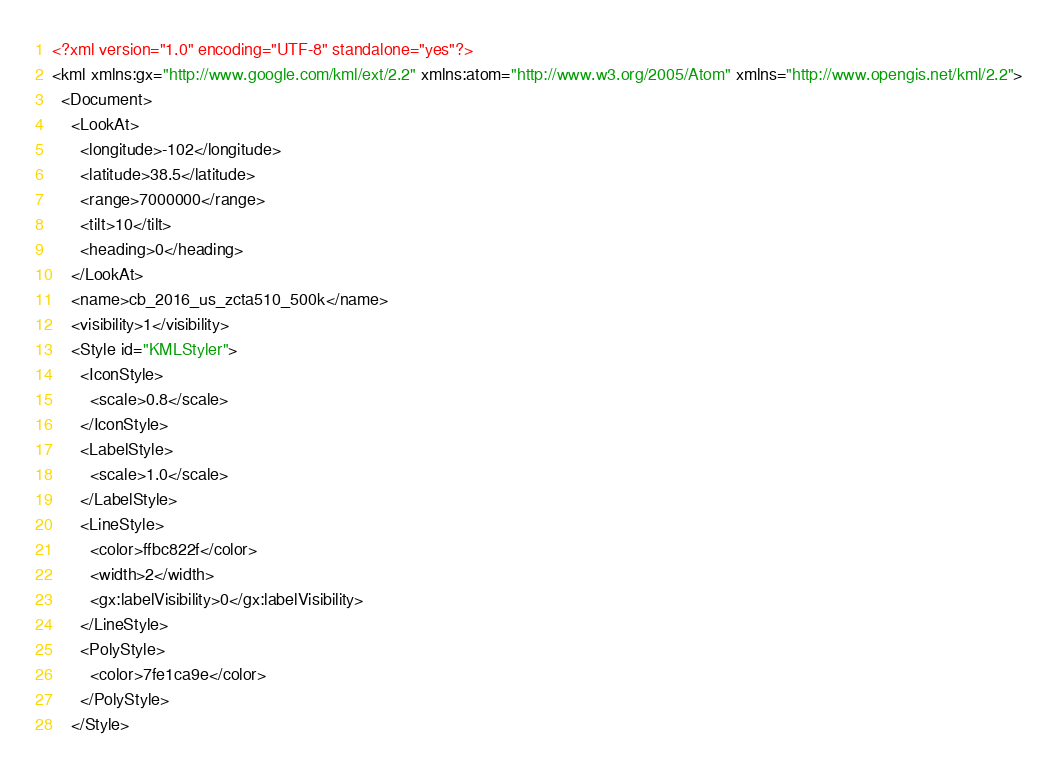<code> <loc_0><loc_0><loc_500><loc_500><_XML_><?xml version="1.0" encoding="UTF-8" standalone="yes"?>
<kml xmlns:gx="http://www.google.com/kml/ext/2.2" xmlns:atom="http://www.w3.org/2005/Atom" xmlns="http://www.opengis.net/kml/2.2">
  <Document>
    <LookAt>
      <longitude>-102</longitude>
      <latitude>38.5</latitude>
      <range>7000000</range>
      <tilt>10</tilt>
      <heading>0</heading>
    </LookAt>
    <name>cb_2016_us_zcta510_500k</name>
    <visibility>1</visibility>
    <Style id="KMLStyler">
      <IconStyle>
        <scale>0.8</scale>
      </IconStyle>
      <LabelStyle>
        <scale>1.0</scale>
      </LabelStyle>
      <LineStyle>
        <color>ffbc822f</color>
        <width>2</width>
        <gx:labelVisibility>0</gx:labelVisibility>
      </LineStyle>
      <PolyStyle>
        <color>7fe1ca9e</color>
      </PolyStyle>
    </Style></code> 